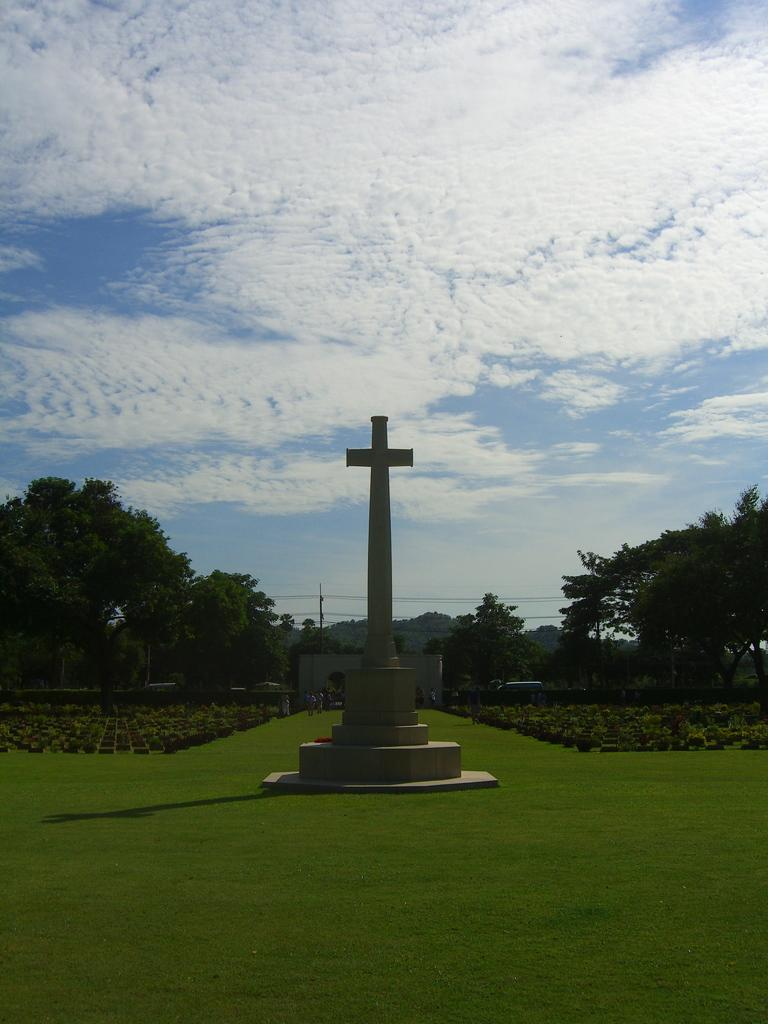What is the main subject in the center of the image? There is a cross in the center of the image. Where is the cross located? The cross is on the grass. What can be seen in the background of the image? There are trees, plants, and the sky visible in the background of the image. What is the condition of the sky in the image? Clouds are present in the sky. What type of vegetation is at the bottom of the image? There is grass at the bottom of the image. What time does the clock show in the image? There is no clock present in the image. How many drops of water can be seen falling from the sky in the image? There are no drops of water visible in the image; only clouds are present in the sky. 